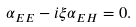<formula> <loc_0><loc_0><loc_500><loc_500>\alpha _ { E E } - i \xi \alpha _ { E H } = 0 .</formula> 